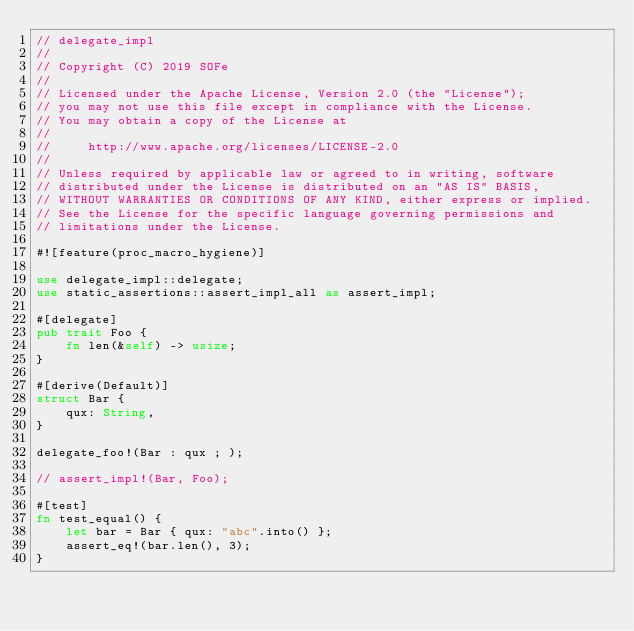Convert code to text. <code><loc_0><loc_0><loc_500><loc_500><_Rust_>// delegate_impl
//
// Copyright (C) 2019 SOFe
//
// Licensed under the Apache License, Version 2.0 (the "License");
// you may not use this file except in compliance with the License.
// You may obtain a copy of the License at
//
//     http://www.apache.org/licenses/LICENSE-2.0
//
// Unless required by applicable law or agreed to in writing, software
// distributed under the License is distributed on an "AS IS" BASIS,
// WITHOUT WARRANTIES OR CONDITIONS OF ANY KIND, either express or implied.
// See the License for the specific language governing permissions and
// limitations under the License.

#![feature(proc_macro_hygiene)]

use delegate_impl::delegate;
use static_assertions::assert_impl_all as assert_impl;

#[delegate]
pub trait Foo {
    fn len(&self) -> usize;
}

#[derive(Default)]
struct Bar {
    qux: String,
}

delegate_foo!(Bar : qux ; );

// assert_impl!(Bar, Foo);

#[test]
fn test_equal() {
    let bar = Bar { qux: "abc".into() };
    assert_eq!(bar.len(), 3);
}
</code> 